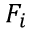<formula> <loc_0><loc_0><loc_500><loc_500>F _ { i }</formula> 